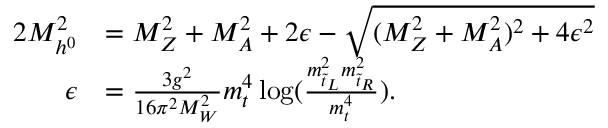<formula> <loc_0><loc_0><loc_500><loc_500>\begin{array} { r l } { { 2 M _ { h ^ { 0 } } ^ { 2 } } } & { { = M _ { Z } ^ { 2 } + M _ { A } ^ { 2 } + 2 \epsilon - \sqrt { ( M _ { Z } ^ { 2 } + M _ { A } ^ { 2 } ) ^ { 2 } + 4 \epsilon ^ { 2 } } } } \\ { \epsilon } & { { = \frac { 3 g ^ { 2 } } { 1 6 \pi ^ { 2 } M _ { W } ^ { 2 } } m _ { t } ^ { 4 } \log ( \frac { m _ { \tilde { t } _ { L } } ^ { 2 } m _ { \tilde { t } _ { R } } ^ { 2 } } { m _ { t } ^ { 4 } } ) . } } \end{array}</formula> 